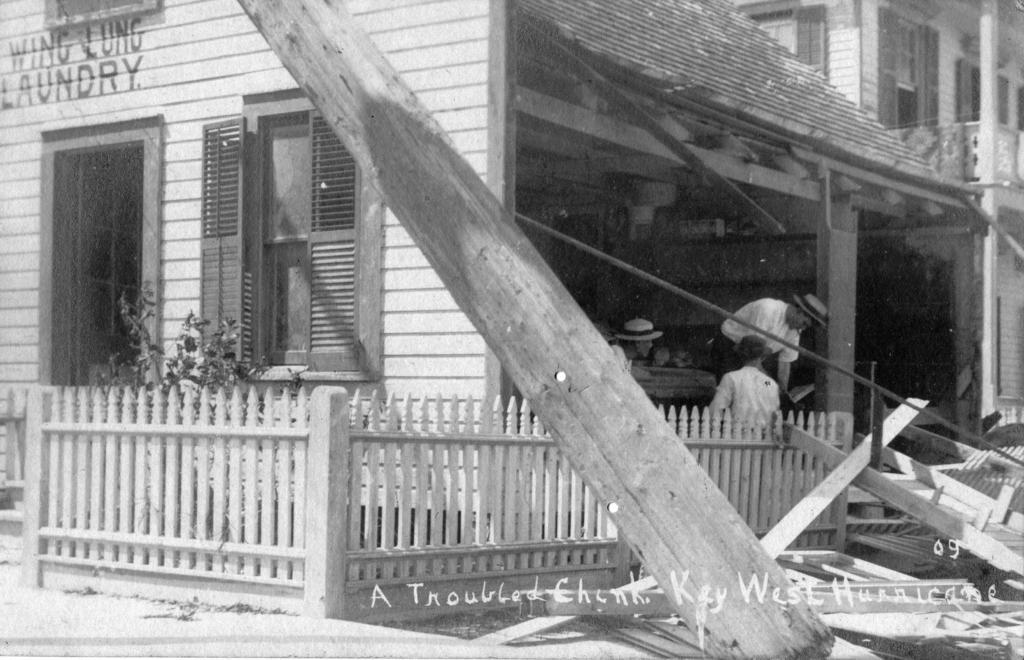Can you describe this image briefly? This is a black and white image. In this picture we can see the buildings, plant, door, window, wall, roof, balcony, fencing and wood logs. At the bottom of the image we can see the floor and some text. In the middle of the image we can see some persons and some of them are wearing hats. 